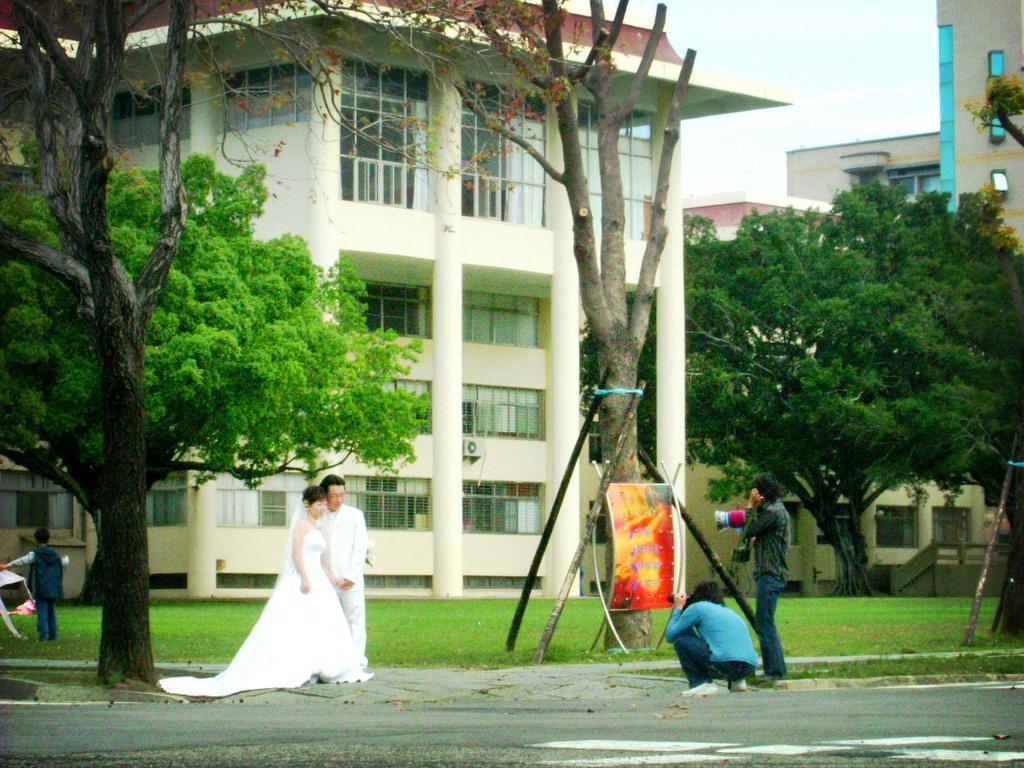In one or two sentences, can you explain what this image depicts? In the image I can see a lady who is wearing gown and the guy in white dress are posing for the picture and in front them there are two people who are holding the cameras and also I can see some trees, plants and buildings. 